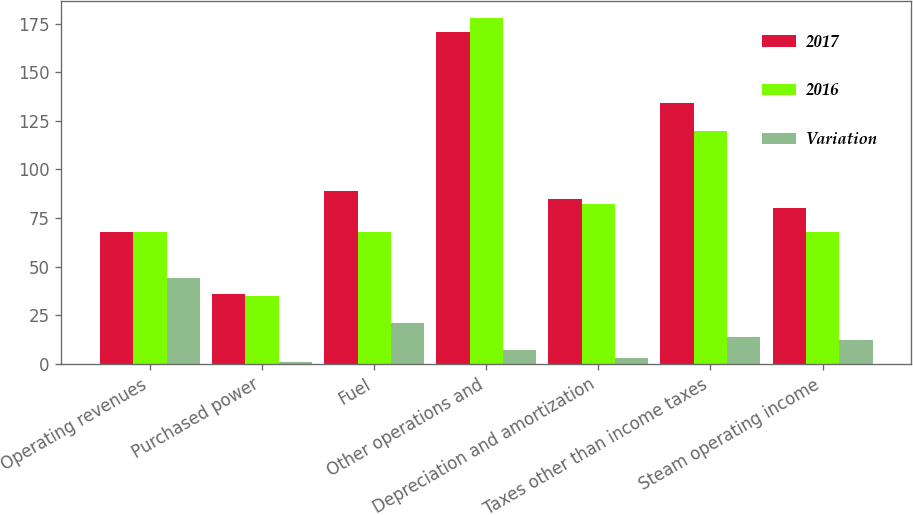<chart> <loc_0><loc_0><loc_500><loc_500><stacked_bar_chart><ecel><fcel>Operating revenues<fcel>Purchased power<fcel>Fuel<fcel>Other operations and<fcel>Depreciation and amortization<fcel>Taxes other than income taxes<fcel>Steam operating income<nl><fcel>2017<fcel>68<fcel>36<fcel>89<fcel>171<fcel>85<fcel>134<fcel>80<nl><fcel>2016<fcel>68<fcel>35<fcel>68<fcel>178<fcel>82<fcel>120<fcel>68<nl><fcel>Variation<fcel>44<fcel>1<fcel>21<fcel>7<fcel>3<fcel>14<fcel>12<nl></chart> 